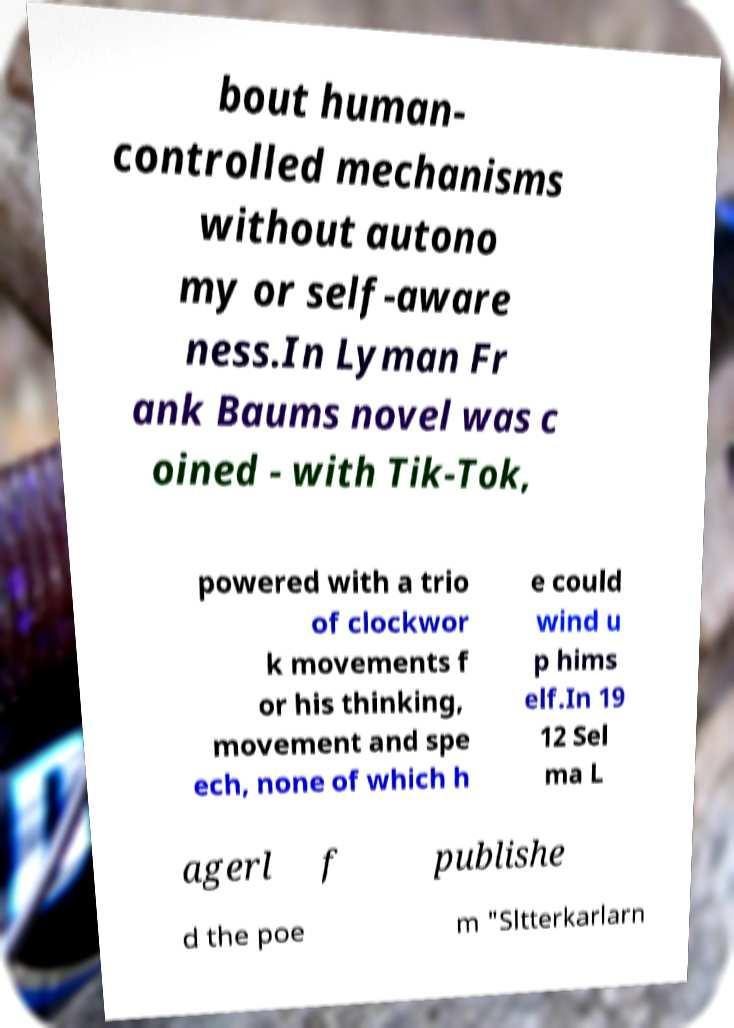What messages or text are displayed in this image? I need them in a readable, typed format. bout human- controlled mechanisms without autono my or self-aware ness.In Lyman Fr ank Baums novel was c oined - with Tik-Tok, powered with a trio of clockwor k movements f or his thinking, movement and spe ech, none of which h e could wind u p hims elf.In 19 12 Sel ma L agerl f publishe d the poe m "Sltterkarlarn 